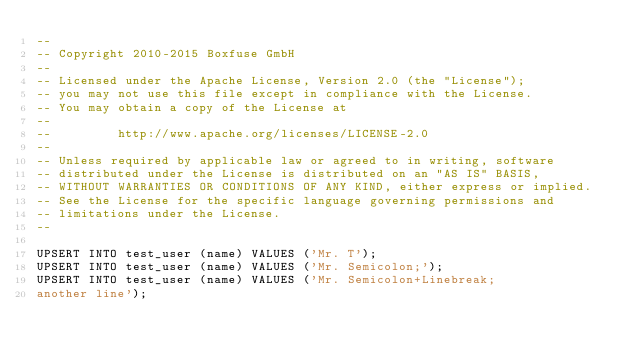<code> <loc_0><loc_0><loc_500><loc_500><_SQL_>--
-- Copyright 2010-2015 Boxfuse GmbH
--
-- Licensed under the Apache License, Version 2.0 (the "License");
-- you may not use this file except in compliance with the License.
-- You may obtain a copy of the License at
--
--         http://www.apache.org/licenses/LICENSE-2.0
--
-- Unless required by applicable law or agreed to in writing, software
-- distributed under the License is distributed on an "AS IS" BASIS,
-- WITHOUT WARRANTIES OR CONDITIONS OF ANY KIND, either express or implied.
-- See the License for the specific language governing permissions and
-- limitations under the License.
--

UPSERT INTO test_user (name) VALUES ('Mr. T');
UPSERT INTO test_user (name) VALUES ('Mr. Semicolon;');
UPSERT INTO test_user (name) VALUES ('Mr. Semicolon+Linebreak;
another line');
</code> 